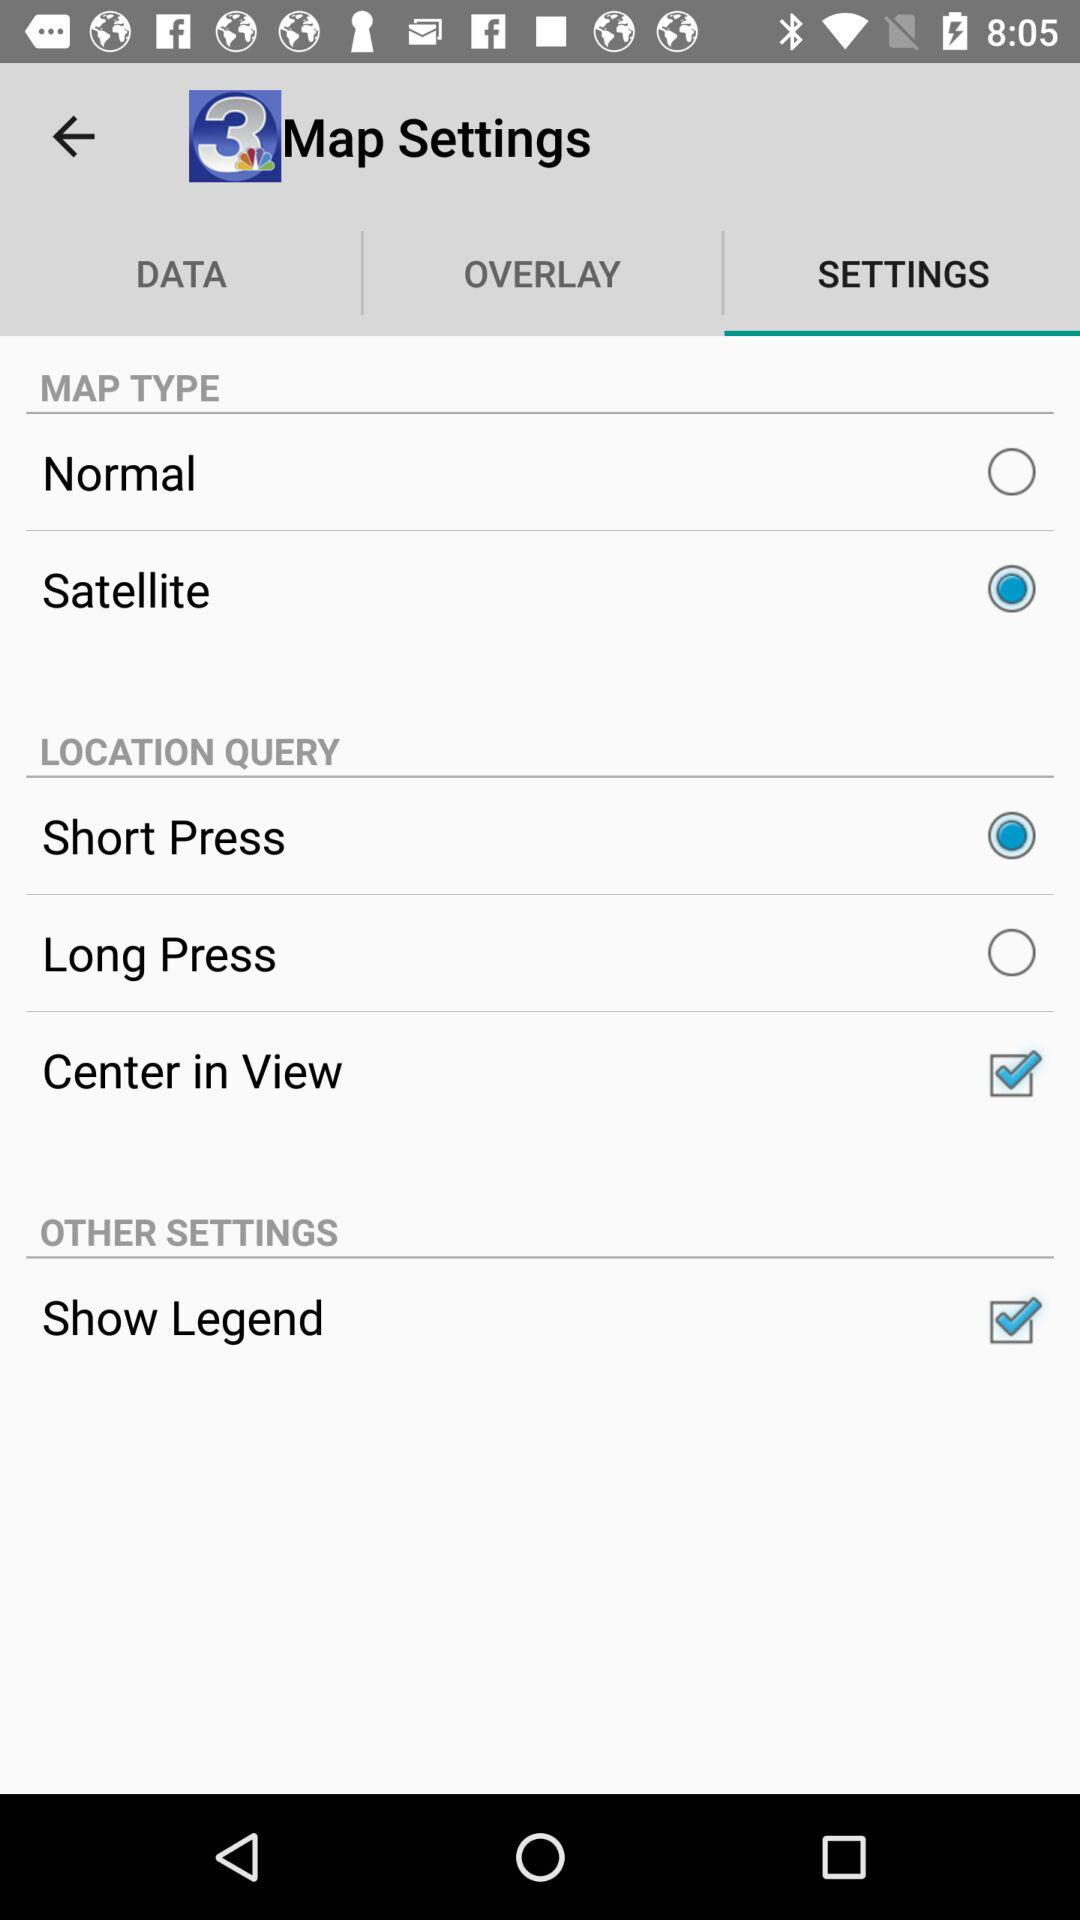What is the application name? The application name is "WSAV News". 